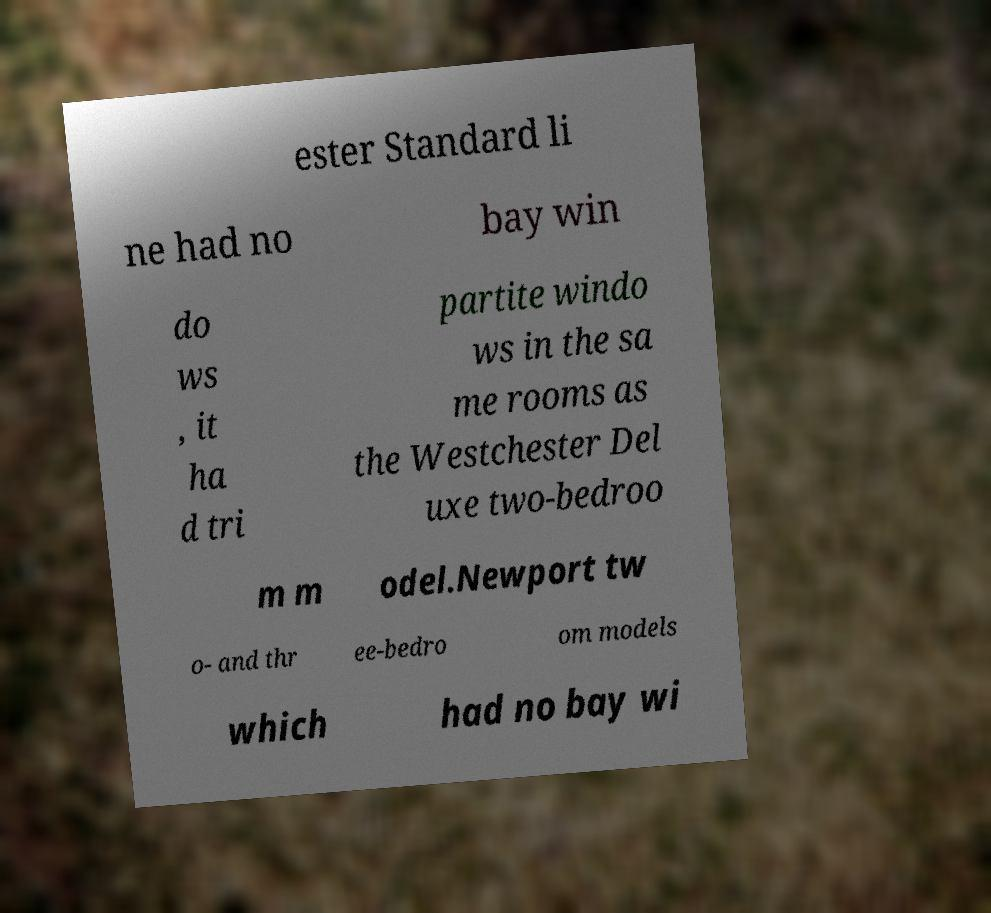I need the written content from this picture converted into text. Can you do that? ester Standard li ne had no bay win do ws , it ha d tri partite windo ws in the sa me rooms as the Westchester Del uxe two-bedroo m m odel.Newport tw o- and thr ee-bedro om models which had no bay wi 